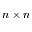Convert formula to latex. <formula><loc_0><loc_0><loc_500><loc_500>n \times n</formula> 